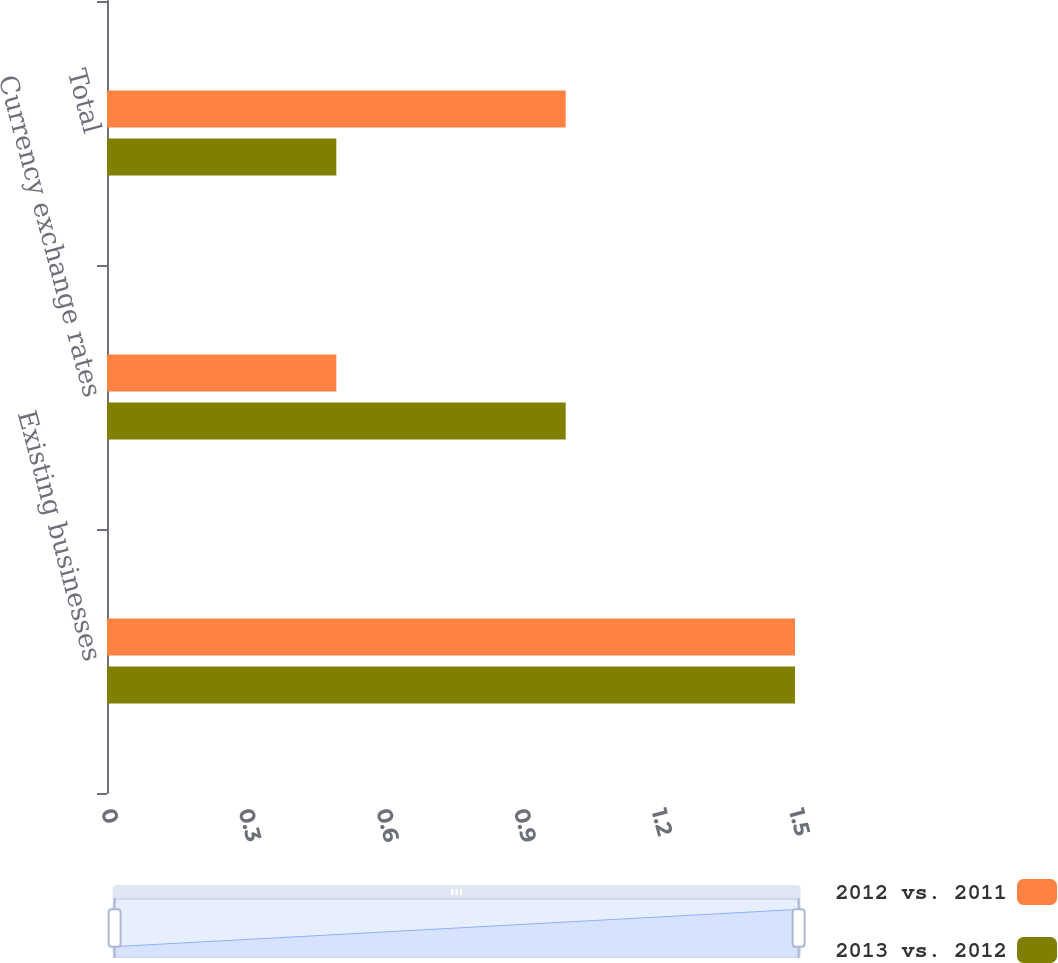Convert chart to OTSL. <chart><loc_0><loc_0><loc_500><loc_500><stacked_bar_chart><ecel><fcel>Existing businesses<fcel>Currency exchange rates<fcel>Total<nl><fcel>2012 vs. 2011<fcel>1.5<fcel>0.5<fcel>1<nl><fcel>2013 vs. 2012<fcel>1.5<fcel>1<fcel>0.5<nl></chart> 